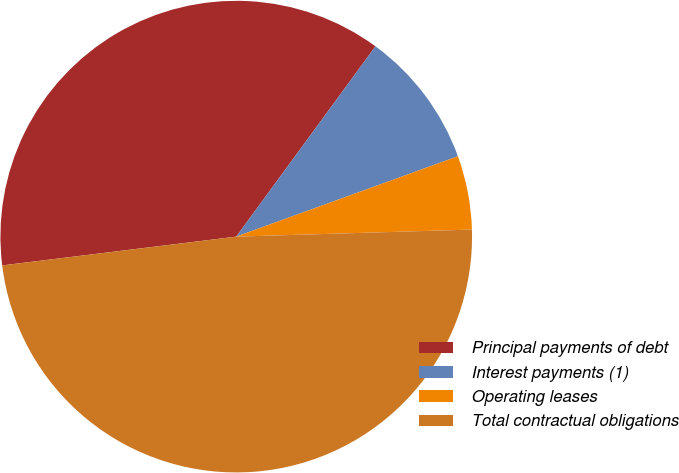Convert chart. <chart><loc_0><loc_0><loc_500><loc_500><pie_chart><fcel>Principal payments of debt<fcel>Interest payments (1)<fcel>Operating leases<fcel>Total contractual obligations<nl><fcel>37.0%<fcel>9.41%<fcel>5.06%<fcel>48.53%<nl></chart> 